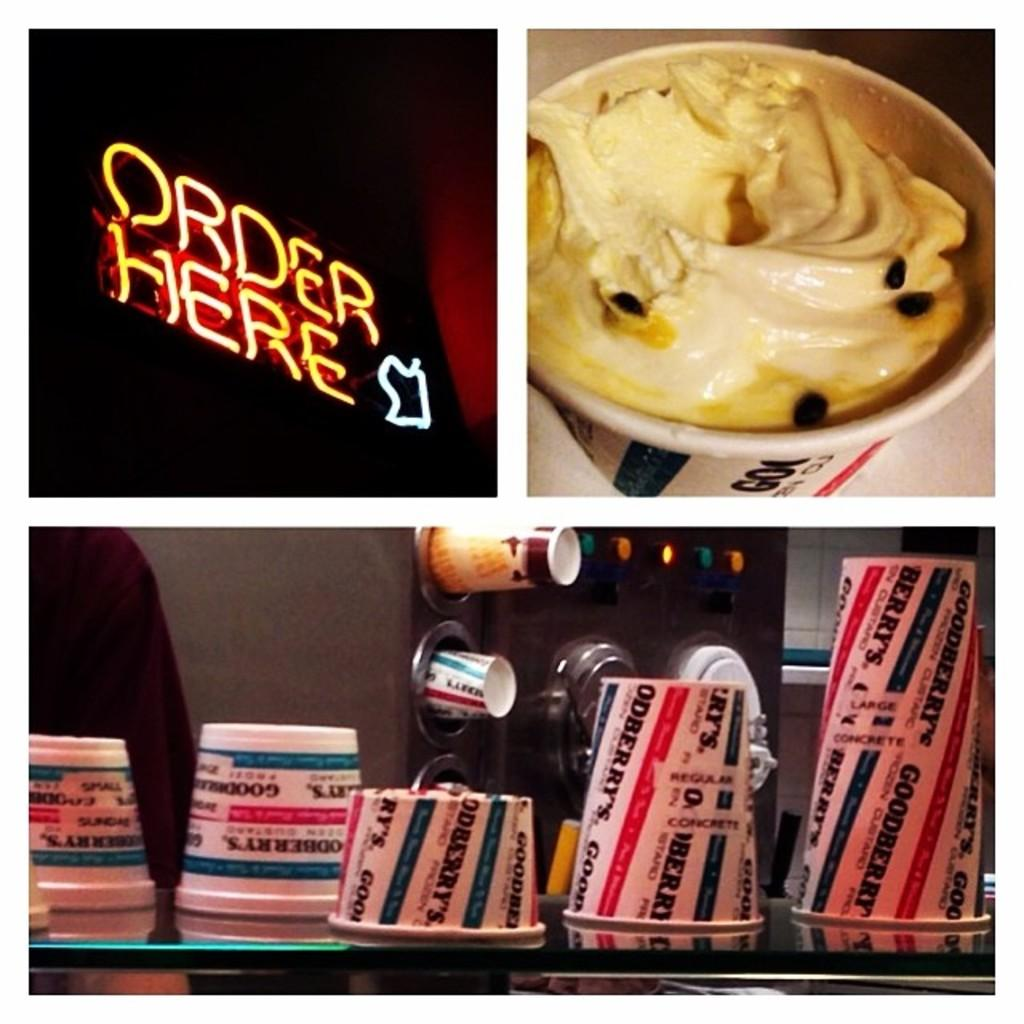<image>
Provide a brief description of the given image. A restaurant sign says Order Here in neon letters next to cups of milkshakes. 